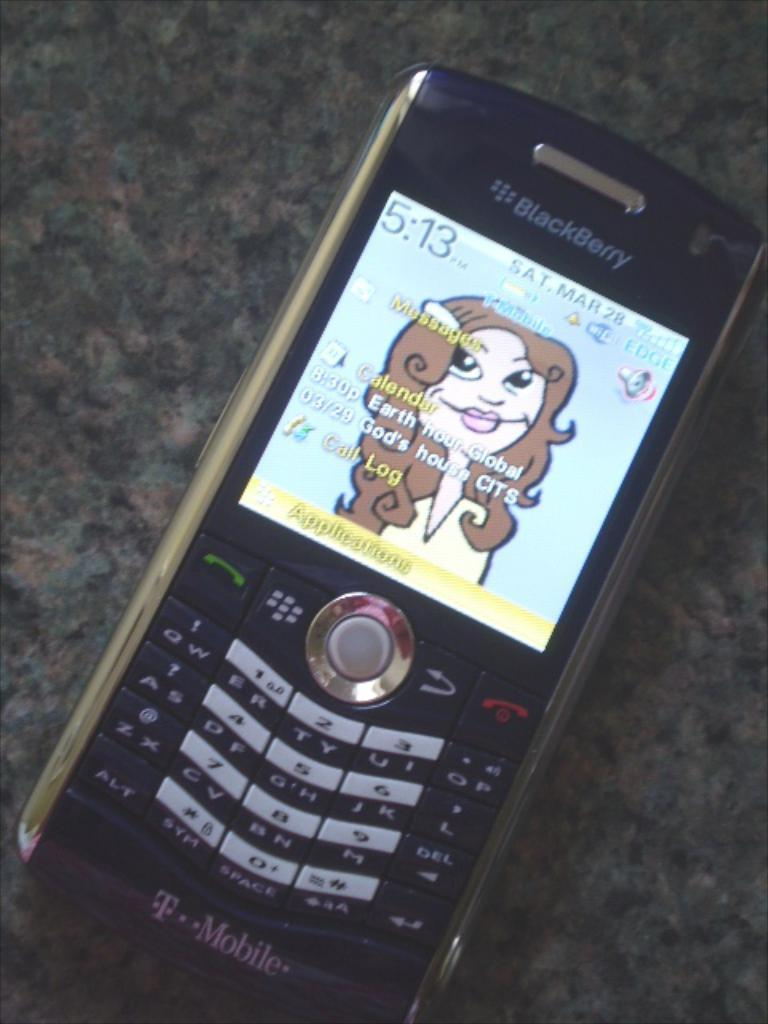<image>
Relay a brief, clear account of the picture shown. a phone that has a call log on it 